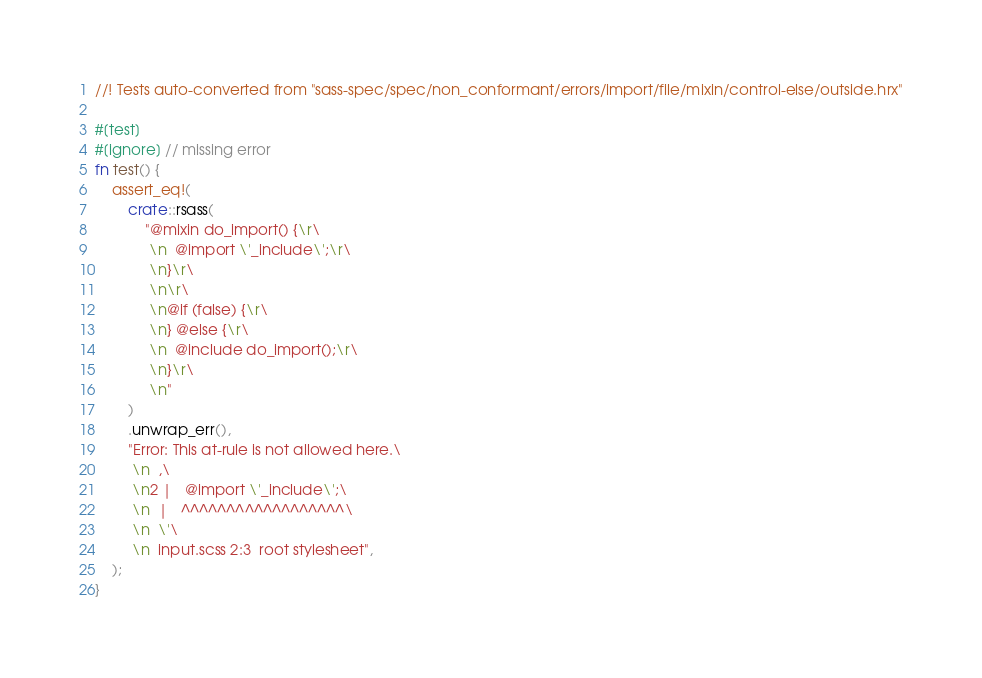<code> <loc_0><loc_0><loc_500><loc_500><_Rust_>//! Tests auto-converted from "sass-spec/spec/non_conformant/errors/import/file/mixin/control-else/outside.hrx"

#[test]
#[ignore] // missing error
fn test() {
    assert_eq!(
        crate::rsass(
            "@mixin do_import() {\r\
             \n  @import \'_include\';\r\
             \n}\r\
             \n\r\
             \n@if (false) {\r\
             \n} @else {\r\
             \n  @include do_import();\r\
             \n}\r\
             \n"
        )
        .unwrap_err(),
        "Error: This at-rule is not allowed here.\
         \n  ,\
         \n2 |   @import \'_include\';\
         \n  |   ^^^^^^^^^^^^^^^^^^\
         \n  \'\
         \n  input.scss 2:3  root stylesheet",
    );
}
</code> 